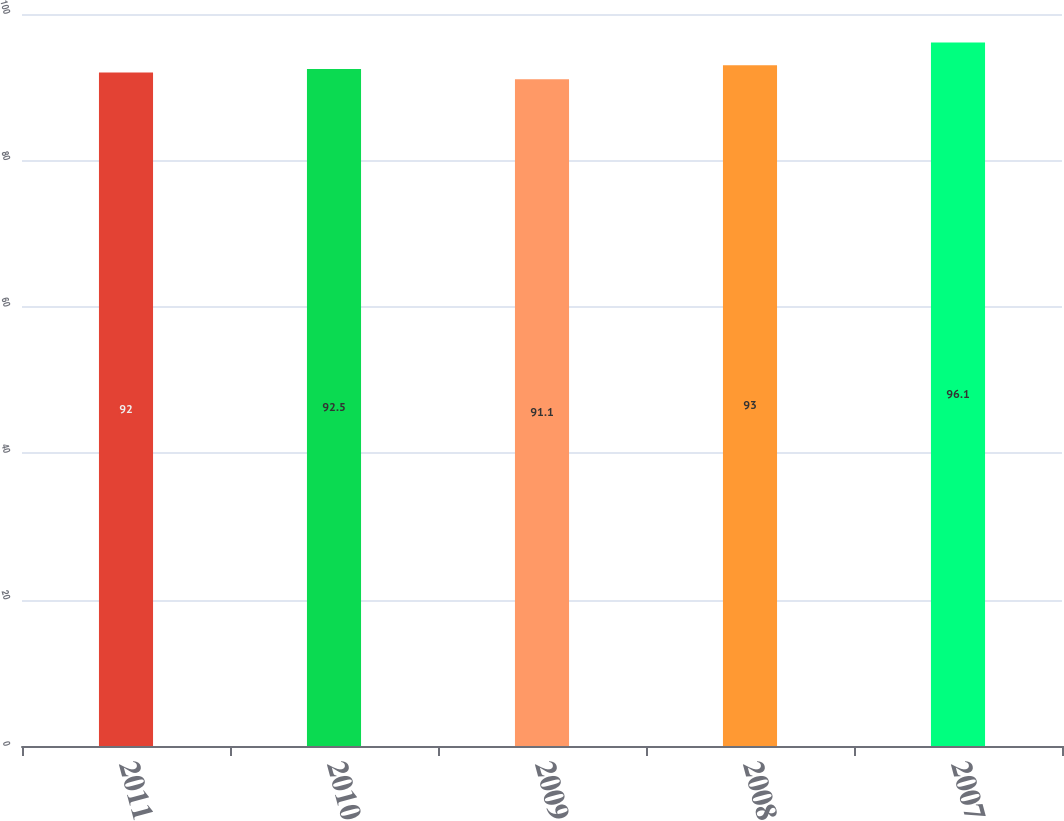Convert chart to OTSL. <chart><loc_0><loc_0><loc_500><loc_500><bar_chart><fcel>2011<fcel>2010<fcel>2009<fcel>2008<fcel>2007<nl><fcel>92<fcel>92.5<fcel>91.1<fcel>93<fcel>96.1<nl></chart> 